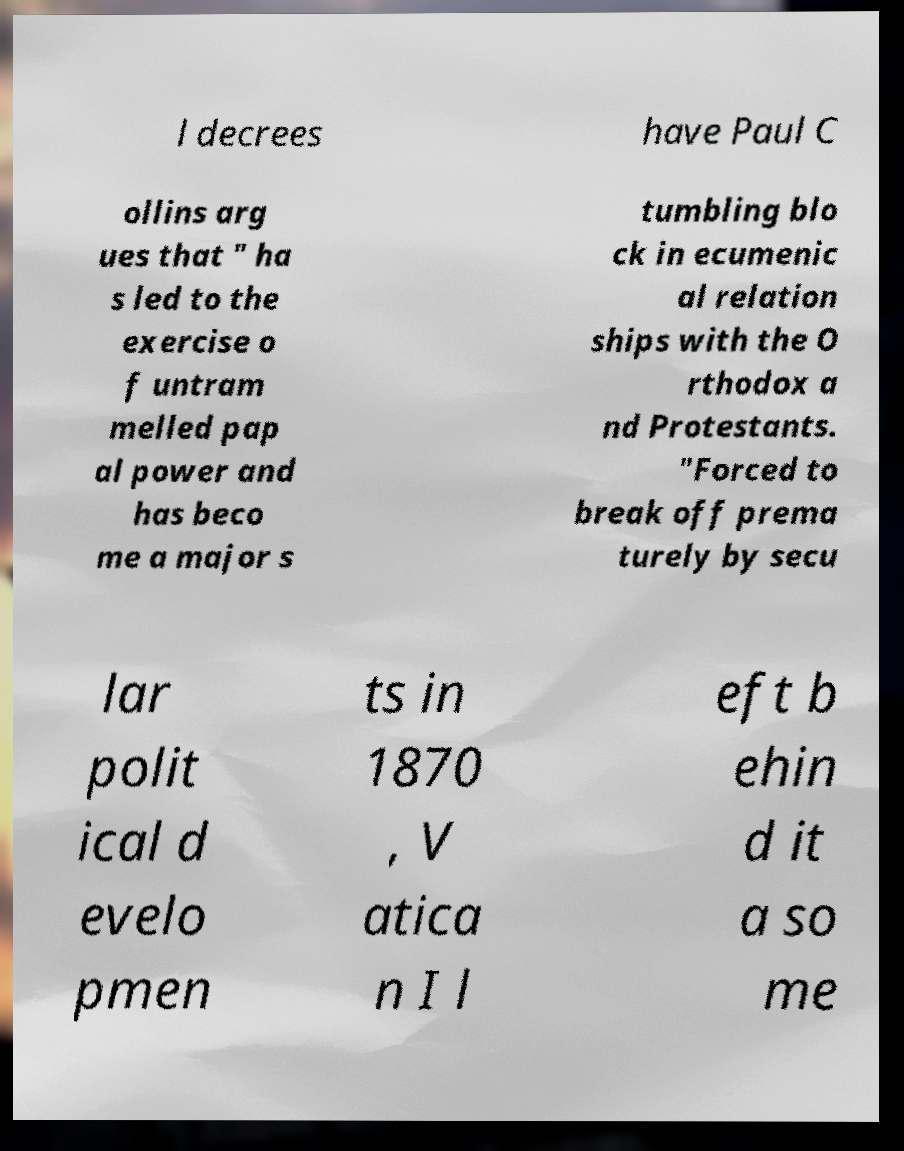Can you read and provide the text displayed in the image?This photo seems to have some interesting text. Can you extract and type it out for me? l decrees have Paul C ollins arg ues that " ha s led to the exercise o f untram melled pap al power and has beco me a major s tumbling blo ck in ecumenic al relation ships with the O rthodox a nd Protestants. "Forced to break off prema turely by secu lar polit ical d evelo pmen ts in 1870 , V atica n I l eft b ehin d it a so me 